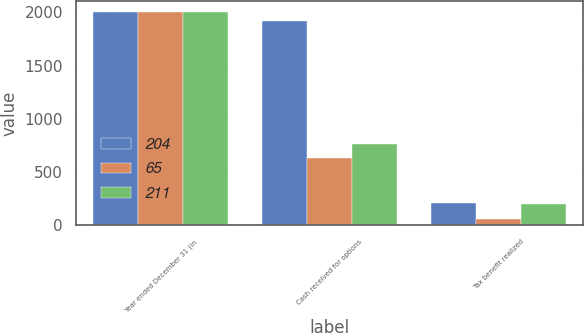<chart> <loc_0><loc_0><loc_500><loc_500><stacked_bar_chart><ecel><fcel>Year ended December 31 (in<fcel>Cash received for options<fcel>Tax benefit realized<nl><fcel>204<fcel>2006<fcel>1924<fcel>211<nl><fcel>65<fcel>2005<fcel>635<fcel>65<nl><fcel>211<fcel>2004<fcel>764<fcel>204<nl></chart> 